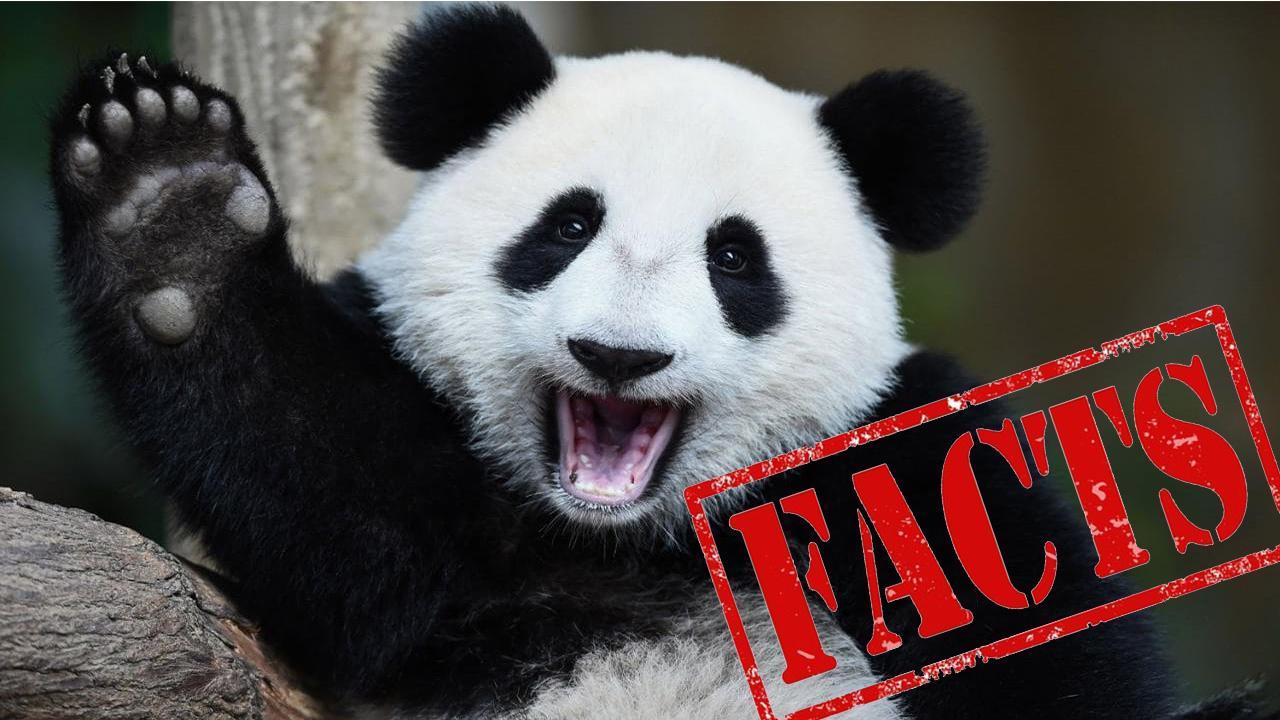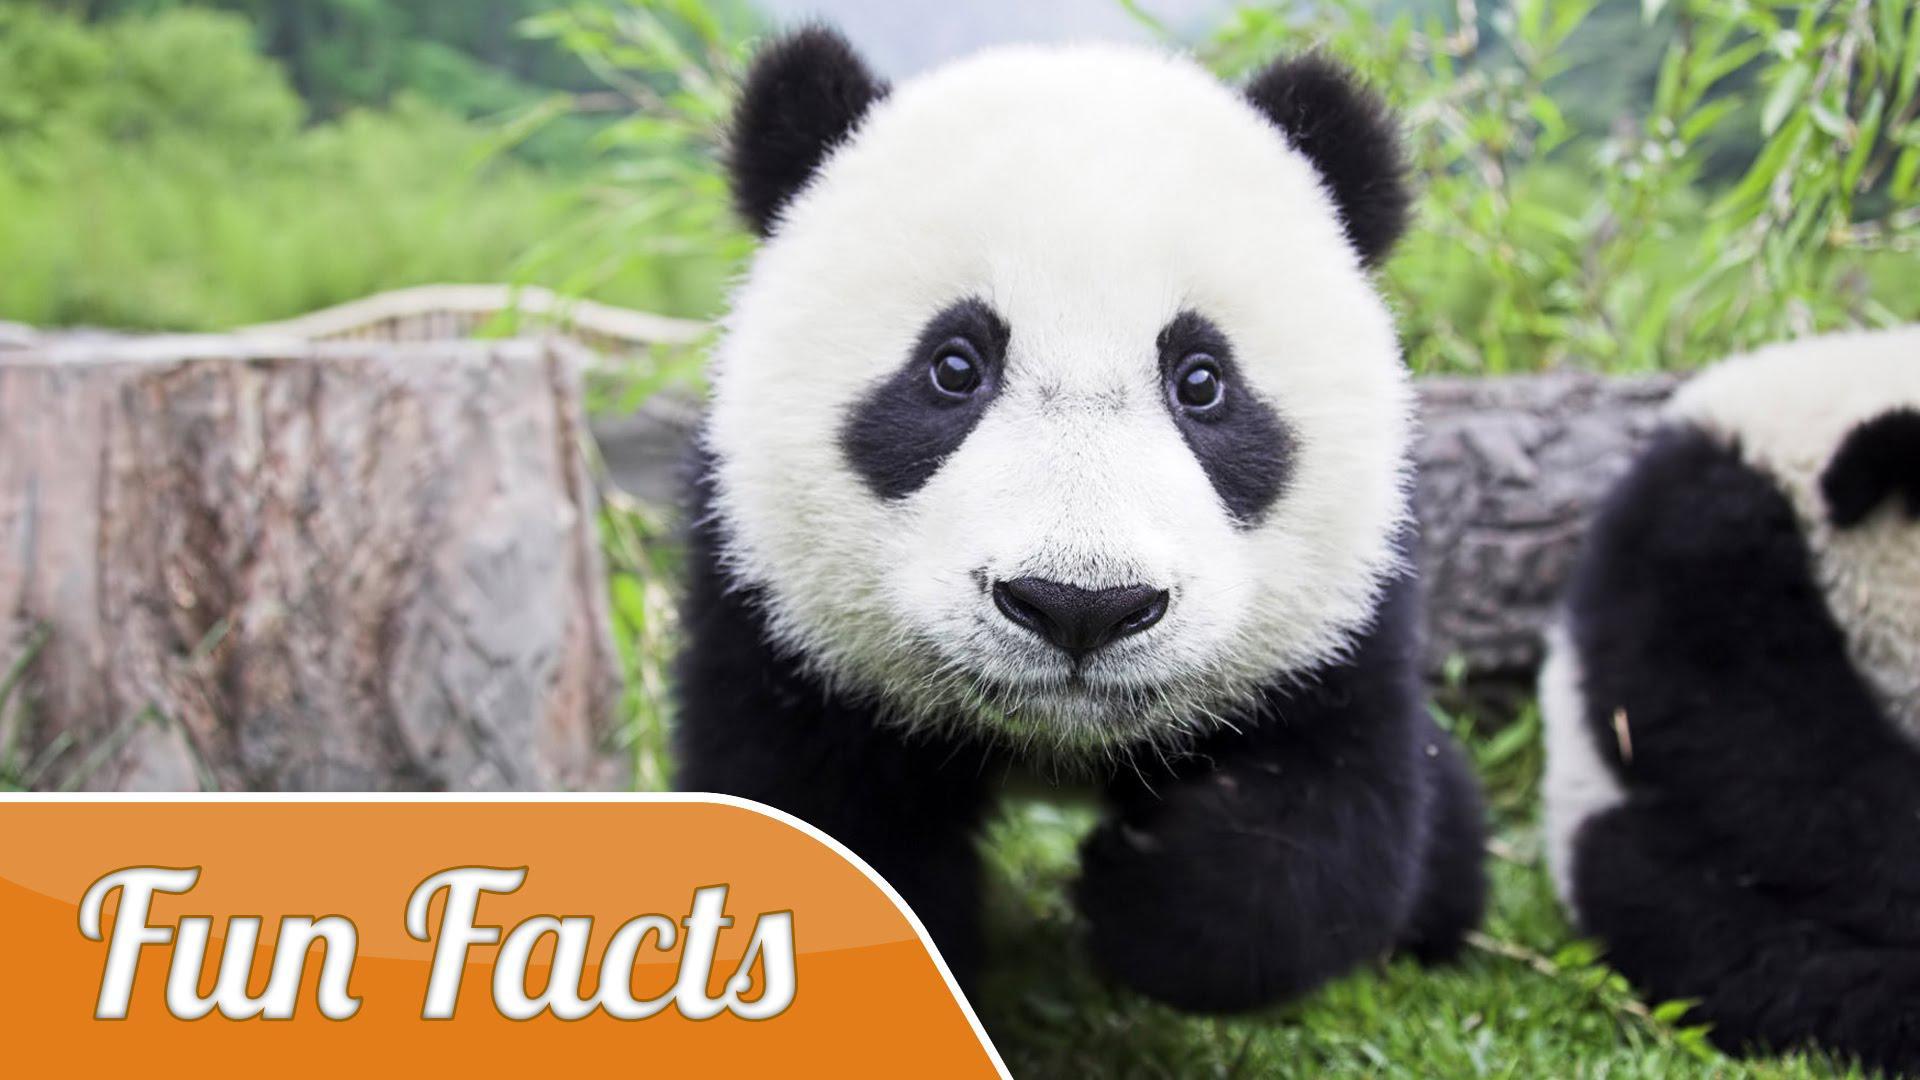The first image is the image on the left, the second image is the image on the right. Considering the images on both sides, is "There's no more than two pandas in the right image." valid? Answer yes or no. Yes. The first image is the image on the left, the second image is the image on the right. Examine the images to the left and right. Is the description "An image includes at least four pandas posed in a horizontal row." accurate? Answer yes or no. No. 